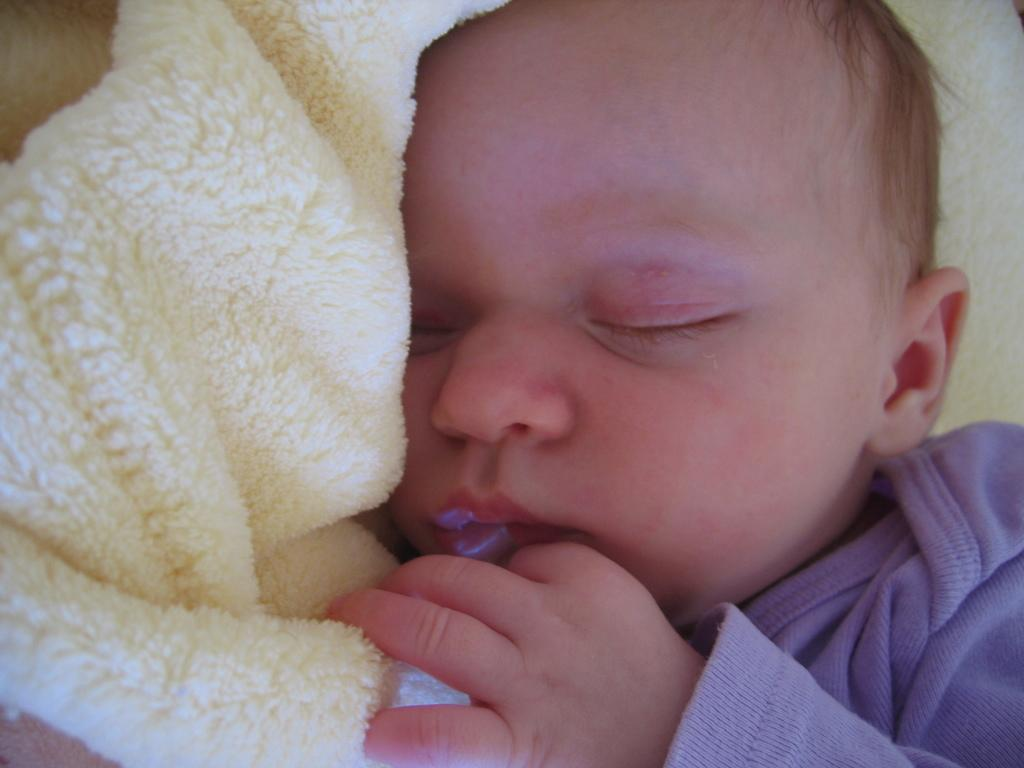What is the main subject of the image? The main subject of the image is a kid. What is the kid wearing in the image? The kid is wearing a blue dress. What is the kid doing in the image? The kid is sleeping. What is the kid sleeping on or in? The kid is sleeping in a towel. Can you describe the color of the towel? The towel is cream-colored. What type of food is the kid eating in the image? There is no indication in the image that the kid is eating any food, so it cannot be determined from the picture. What channel is the kid watching on the television in the image? There is no television present in the image. How many ducks are visible in the image? There are no ducks present in the image. 